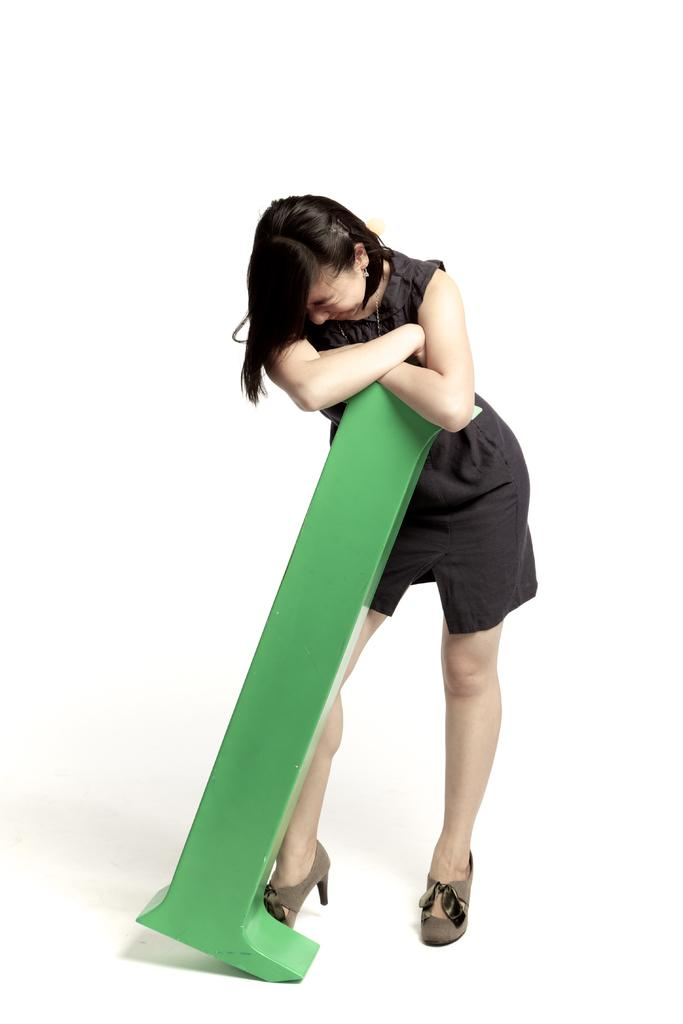Who is the main subject in the image? There is a person in the center of the image. What is the person wearing? The person is wearing a black dress. What is the person holding in the image? The person is holding a green object. What is the person standing on? The person is standing on the ground. What color is the background of the image? The background of the image is white in color. What type of substance is being exchanged between the dolls in the image? There are no dolls present in the image, and therefore no substance exchange can be observed. 